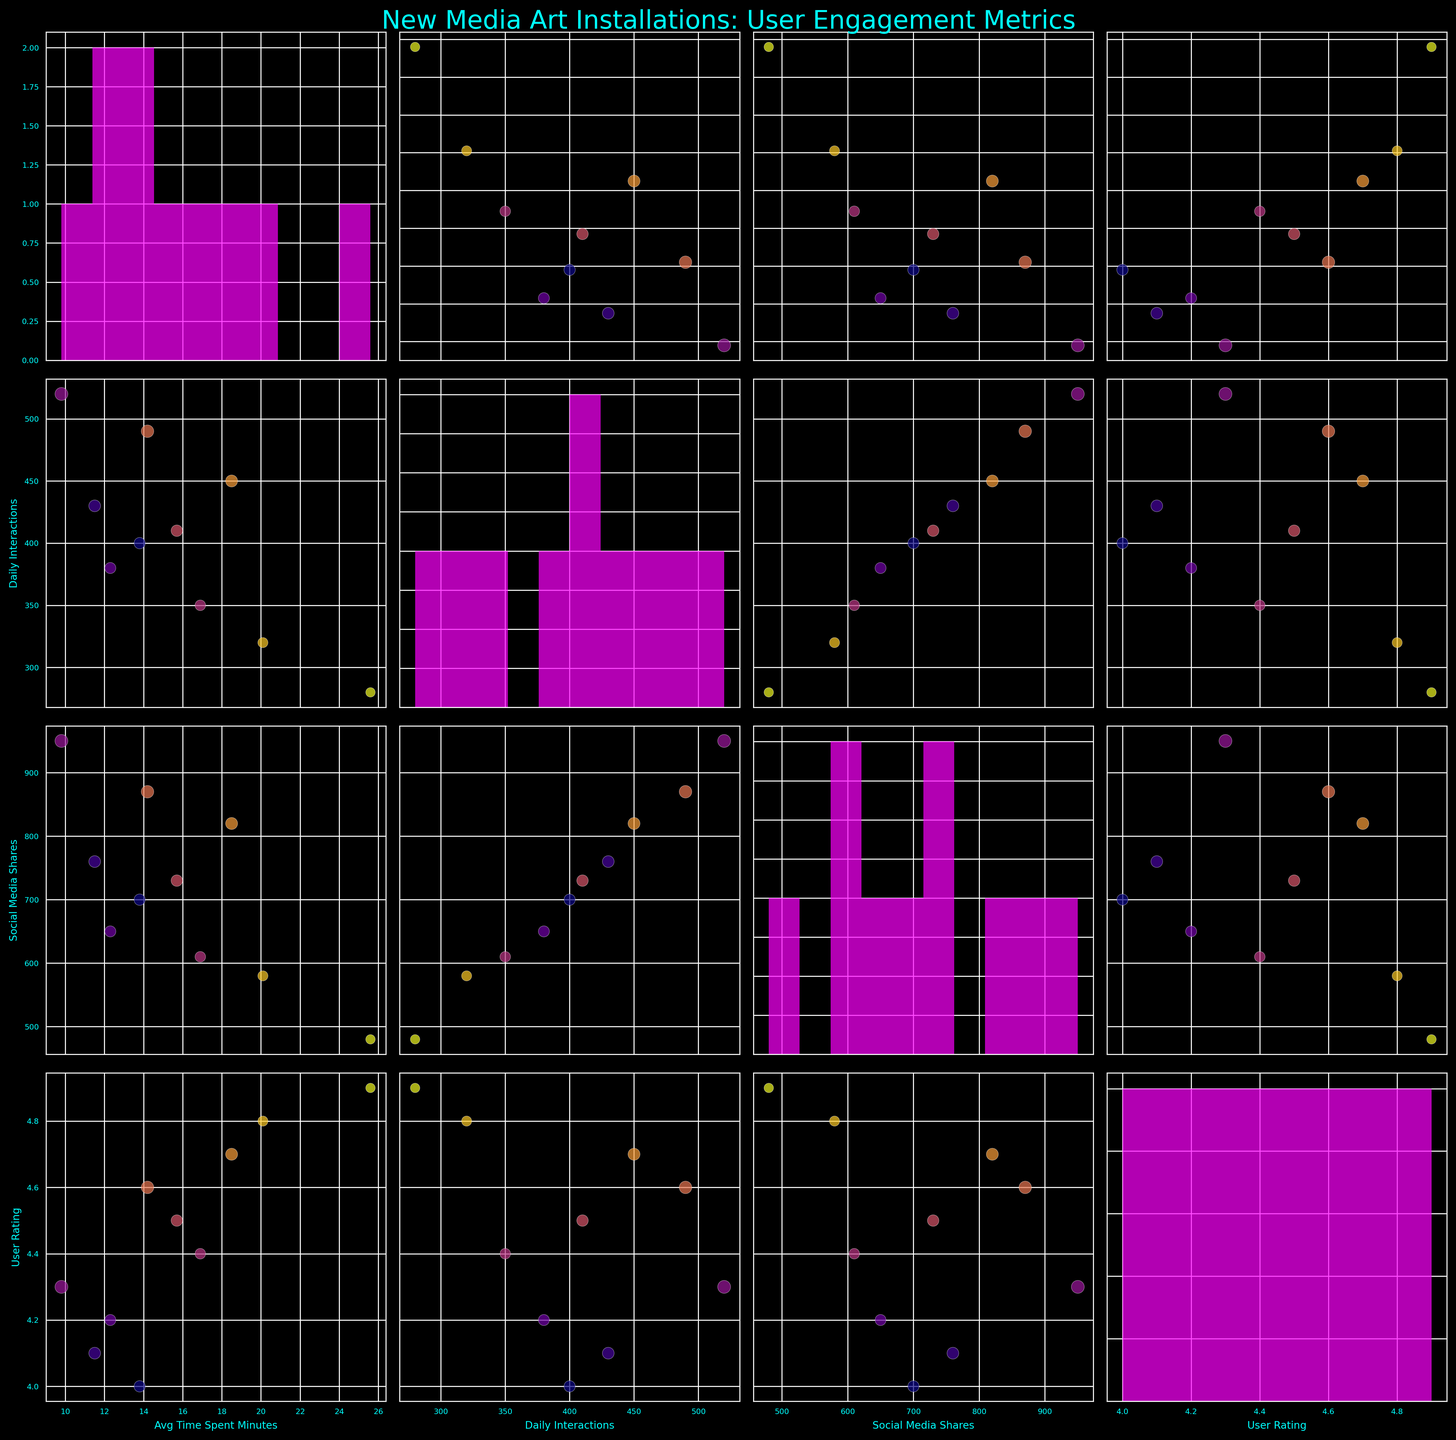What's the title of the figure? Look at the top of the figure to see the headline.
Answer: New Media Art Installations: User Engagement Metrics Which engagement metric has the highest average time spent by users? Find the metric with the highest value along the 'Avg Time Spent Minutes' axis in the histograms.
Answer: Virtual Reality Experience How does the 'Daily Interactions' of the 'Augmented Reality Mural' compare to the 'Virtual Reality Experience'? Look at the scatter plot where 'Daily Interactions' is plotted against 'Avg Time Spent Minutes'. Locate both the 'Augmented Reality Mural' and the 'Virtual Reality Experience' data points along the y-axis which corresponds to 'Daily Interactions'.
Answer: Higher for Augmented Reality Mural Which installation has the highest user rating, and what is its social media shares value? Find the scatter plot where 'User Rating' is plotted against 'Social Media Shares'. Locate the data point with the highest value on the 'User Rating' axis and read off its 'Social Media Shares' value.
Answer: Virtual Reality Experience, 480 What color scheme is used to represent user ratings in the scatter plots? Look at the legend or color scale provided in the plots to identify the color scheme used.
Answer: Plasma Which installation had the lowest 'Avg Time Spent Minutes' and how many social media shares did it get? Find the scatter plot where 'Avg Time Spent Minutes' is plotted against 'Social Media Shares'. Look for the lowest value on the 'Avg Time Spent Minutes' axis and read the corresponding 'Social Media Shares' value.
Answer: Augmented Reality Mural, 950 How do 'Avg Time Spent Minutes' and 'User Rating' correlate for 'Infinity Room' and 'Interactive Soundscape'? Look at the scatter plot where 'Avg Time Spent Minutes' is plotted against 'User Rating' and find the data points for 'Infinity Room' and 'Interactive Soundscape'. Compare their positions on both axes.
Answer: Higher for Interactive Soundscape than Infinity Room Which two installations have the closest 'Daily Interactions'? Find the scatter plot where 'Daily Interactions' is plotted against another metric and look for the two data points that are closest along the 'Daily Interactions' axis.
Answer: Holographic Sculpture and Kinetic Light Installation How does the 'Avg Time Spent Minutes' relate to 'Daily Interactions' for 'Projection Mapping Show'? Locate 'Projection Mapping Show' in the scatter plot where 'Avg Time Spent Minutes' is plotted against 'Daily Interactions'. Compare its position on both axes to understand their relationship.
Answer: Moderate 'Avg Time Spent Minutes' and high 'Daily Interactions' 